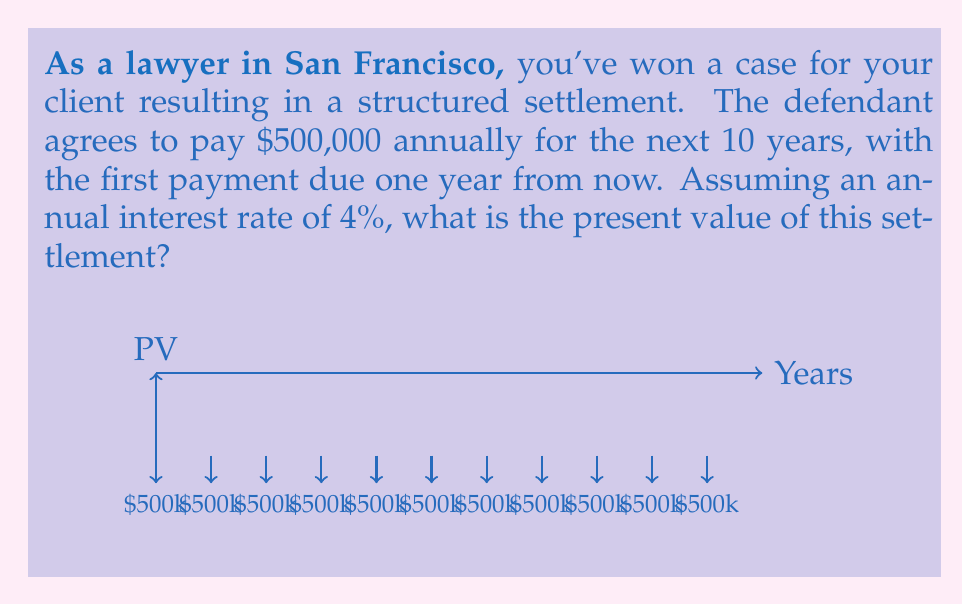What is the answer to this math problem? To solve this problem, we need to use the present value of an annuity formula:

$$ PV = PMT \times \frac{1 - (1+r)^{-n}}{r} $$

Where:
- PV = Present Value
- PMT = Payment amount
- r = Interest rate (as a decimal)
- n = Number of payments

Given:
- PMT = $500,000
- r = 4% = 0.04
- n = 10 years

Let's substitute these values into the formula:

$$ PV = 500,000 \times \frac{1 - (1+0.04)^{-10}}{0.04} $$

Now, let's solve step-by-step:

1) First, calculate $(1+0.04)^{-10}$:
   $$(1.04)^{-10} \approx 0.6756$$

2) Subtract this from 1:
   $$1 - 0.6756 = 0.3244$$

3) Divide by 0.04:
   $$\frac{0.3244}{0.04} = 8.1100$$

4) Multiply by 500,000:
   $$500,000 \times 8.1100 = 4,055,000$$

Therefore, the present value of the settlement is $4,055,000.
Answer: $4,055,000 